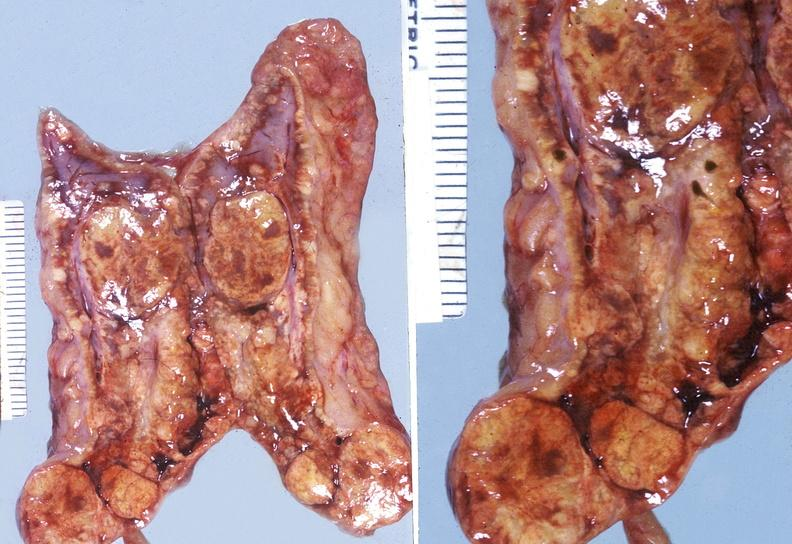s endocrine present?
Answer the question using a single word or phrase. Yes 